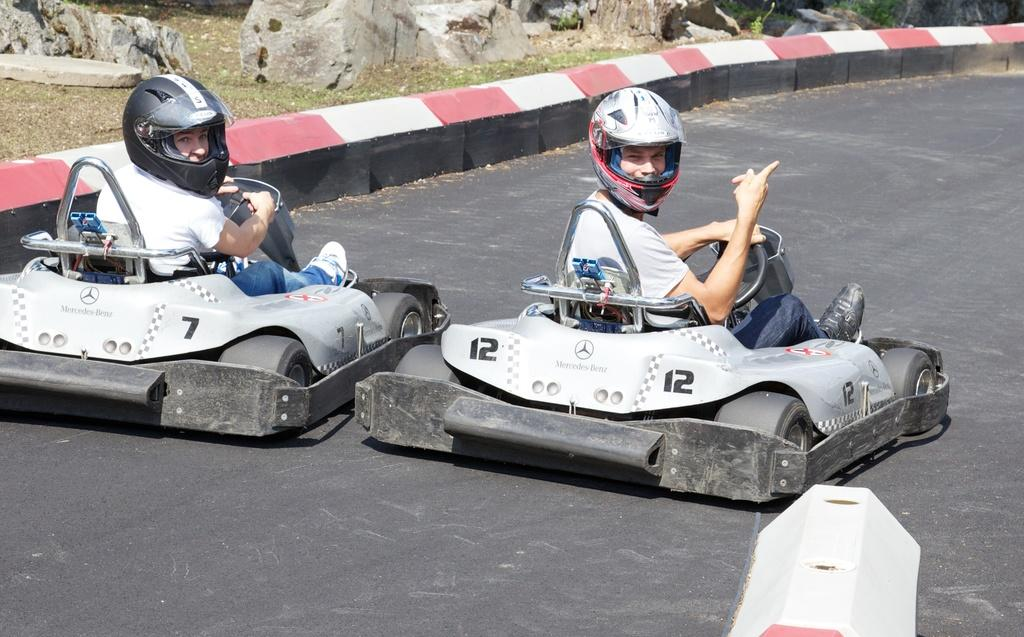How many people are in the image? There are two persons in the image. What are the persons doing in the image? The persons are riding two vehicles. Where are the vehicles located in the image? The vehicles are on the road. What can be seen in the background of the image? There are stones and grass in the background of the image. What is present on the right at the bottom of the image? There is a divider on the right at the bottom of the image. What type of curtain is hanging from the trees in the image? There are no curtains present in the image; it features two persons riding vehicles on the road with stones and grass in the background and a divider on the right at the bottom. 